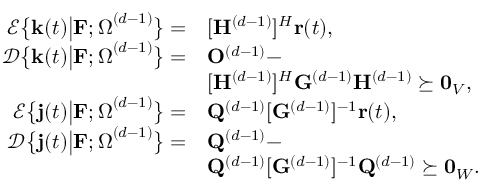<formula> <loc_0><loc_0><loc_500><loc_500>\begin{array} { r l } { \mathcal { E } \left \{ k ( t ) \left | F ; \Omega ^ { ( d - 1 ) } \right \} = } & { [ H ^ { ( d - 1 ) } ] ^ { H } r ( t ) , } \\ { \mathcal { D } \left \{ k ( t ) \right | F ; \Omega ^ { ( d - 1 ) } \right \} = } & { O ^ { ( d - 1 ) } - } \\ & { [ H ^ { ( d - 1 ) } ] ^ { H } G ^ { ( d - 1 ) } H ^ { ( d - 1 ) } \succeq 0 _ { V } , } \\ { \mathcal { E } \left \{ j ( t ) \left | F ; \Omega ^ { ( d - 1 ) } \right \} = } & { Q ^ { ( d - 1 ) } [ G ^ { ( d - 1 ) } ] ^ { - 1 } r ( t ) , } \\ { \mathcal { D } \left \{ j ( t ) \right | F ; \Omega ^ { ( d - 1 ) } \right \} = } & { Q ^ { ( d - 1 ) } - } \\ & { Q ^ { ( d - 1 ) } [ G ^ { ( d - 1 ) } ] ^ { - 1 } Q ^ { ( d - 1 ) } \succeq 0 _ { W } . } \end{array}</formula> 